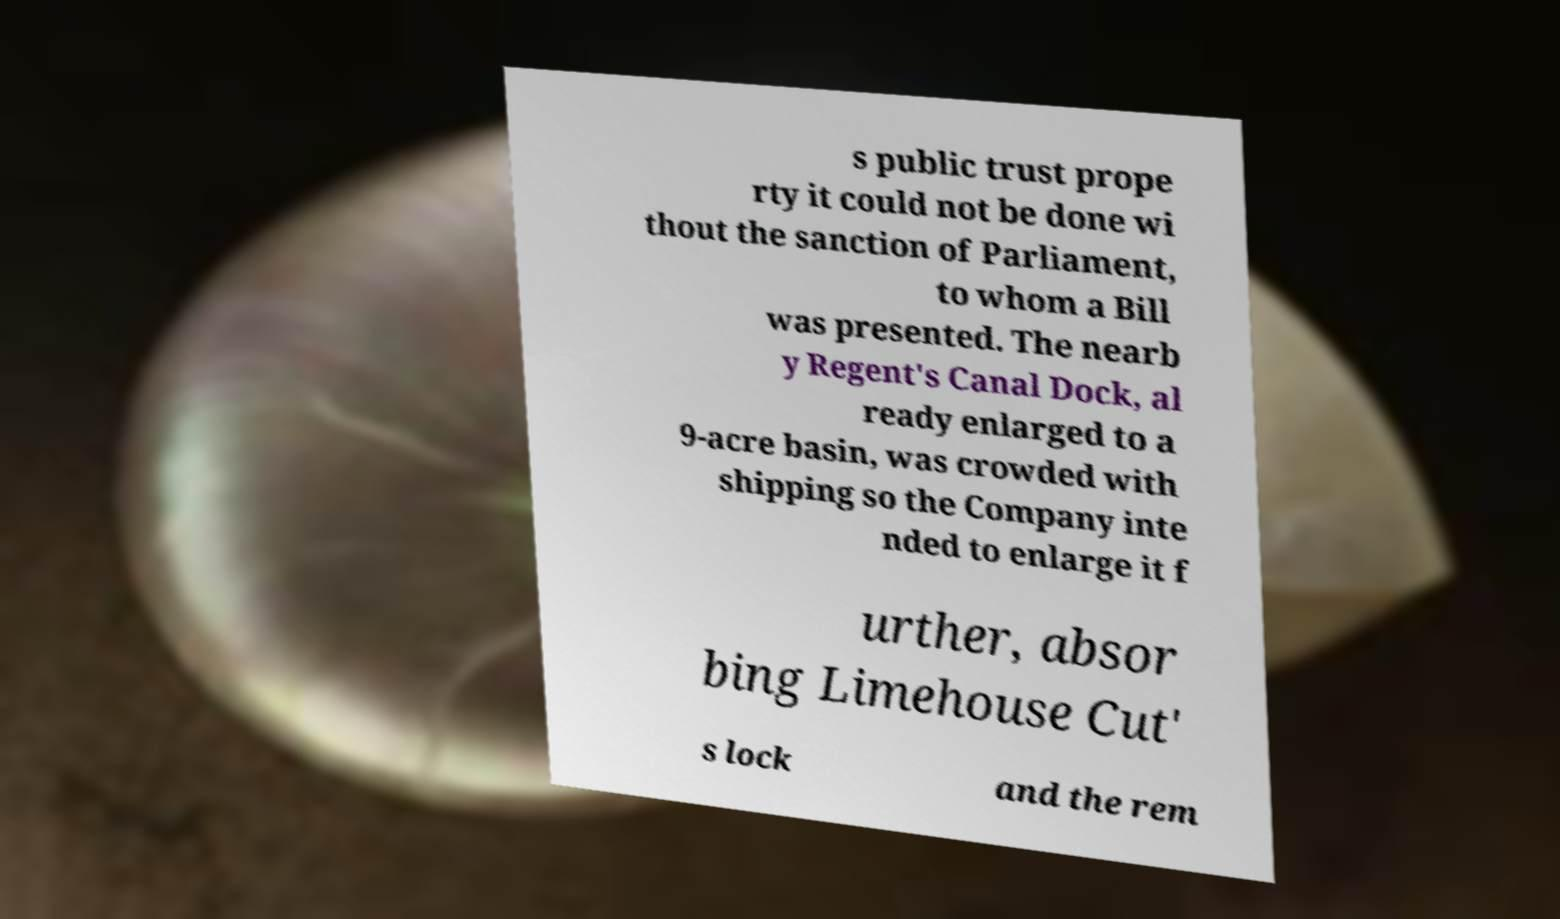Can you read and provide the text displayed in the image?This photo seems to have some interesting text. Can you extract and type it out for me? s public trust prope rty it could not be done wi thout the sanction of Parliament, to whom a Bill was presented. The nearb y Regent's Canal Dock, al ready enlarged to a 9-acre basin, was crowded with shipping so the Company inte nded to enlarge it f urther, absor bing Limehouse Cut' s lock and the rem 